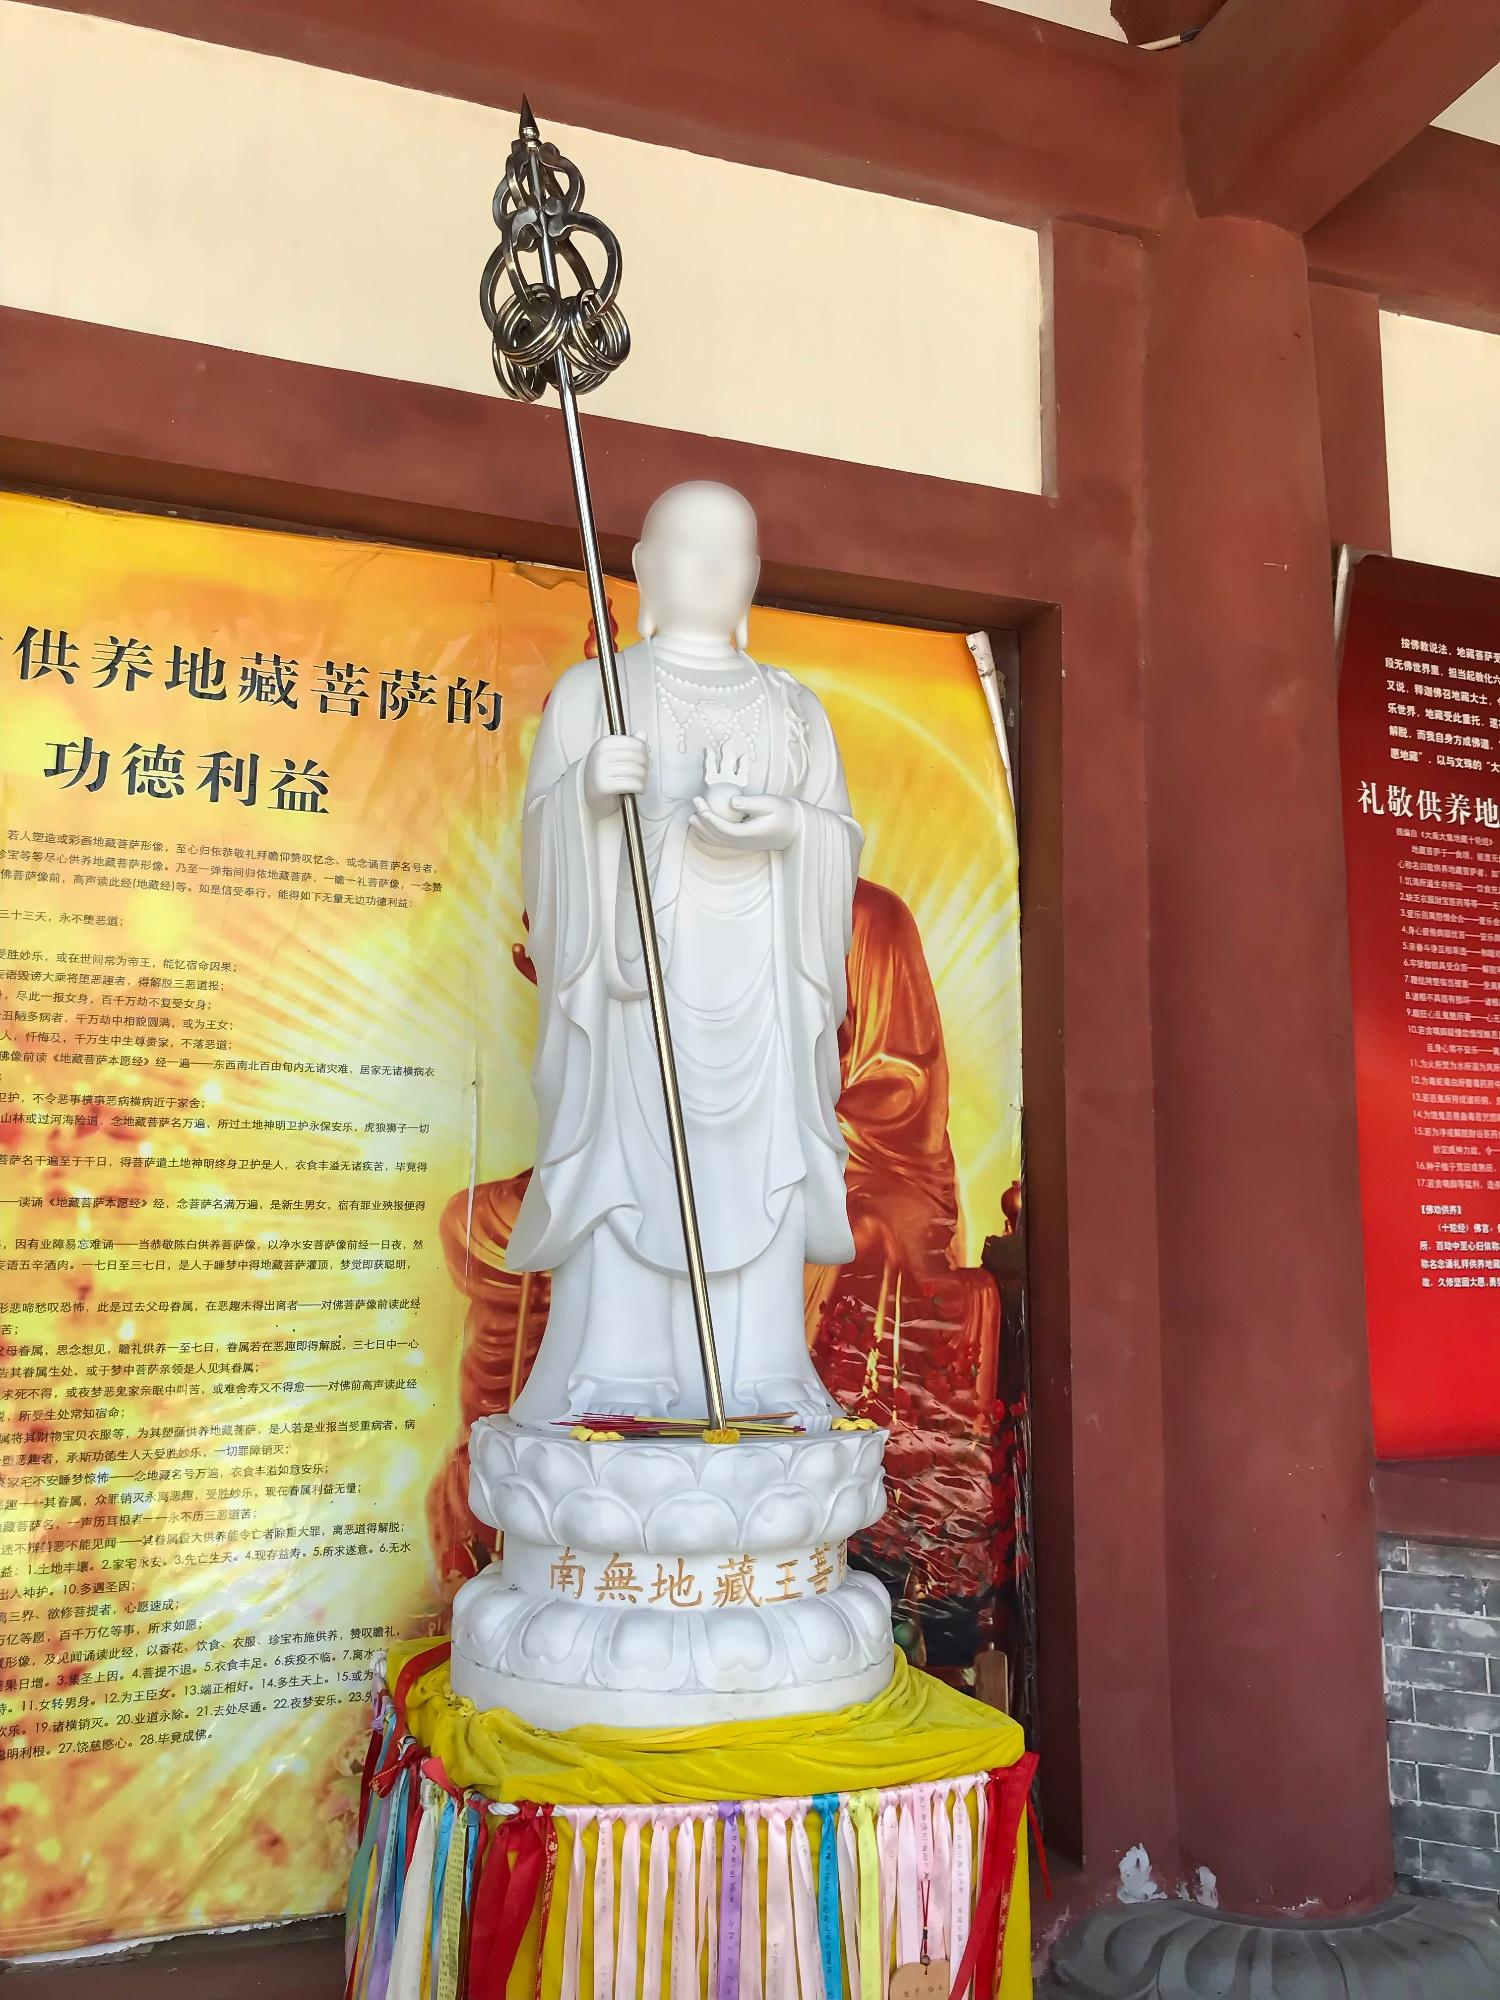Describe the following image. The image features a white sculpture that likely represents an important figure in Buddhism, depicted with a staff and positioned on a round pedestal with intricate detailing. The pedestal showcases Chinese characters, suggesting a phrase or possibly a name associated with the figure. The statue is set against a richly hued backdrop; a vertical yellow banner on the left is filled with Chinese script, while a red panel on the right displays further characters. The lighting and angle of the photograph give the scene a sense of tranquility and reverence, characteristic of a spiritual or religious setting. The brightly colored cloth swatches surrounding the statue's base contribute a lively contrast to the statue's serene white, and the arrangement suggests that this may be a site of veneration or ceremony. 